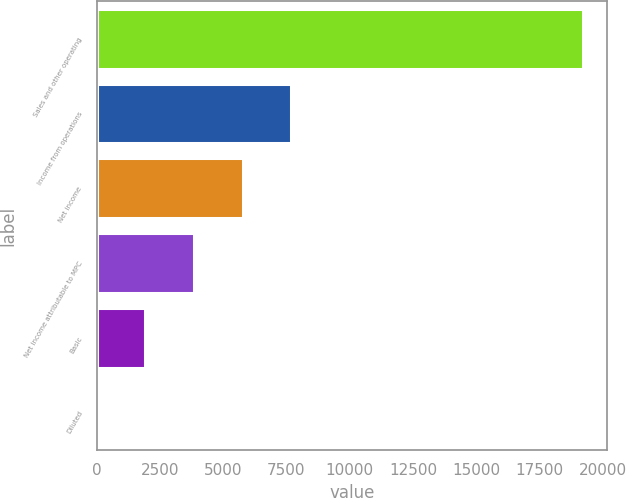Convert chart to OTSL. <chart><loc_0><loc_0><loc_500><loc_500><bar_chart><fcel>Sales and other operating<fcel>Income from operations<fcel>Net income<fcel>Net income attributable to MPC<fcel>Basic<fcel>Diluted<nl><fcel>19210<fcel>7685.05<fcel>5764.23<fcel>3843.41<fcel>1922.59<fcel>1.77<nl></chart> 